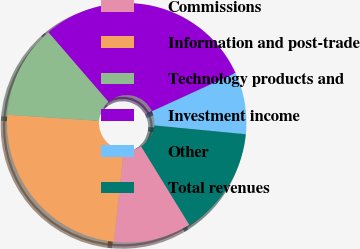Convert chart to OTSL. <chart><loc_0><loc_0><loc_500><loc_500><pie_chart><fcel>Commissions<fcel>Information and post-trade<fcel>Technology products and<fcel>Investment income<fcel>Other<fcel>Total revenues<nl><fcel>10.47%<fcel>24.37%<fcel>12.59%<fcel>29.51%<fcel>8.36%<fcel>14.7%<nl></chart> 